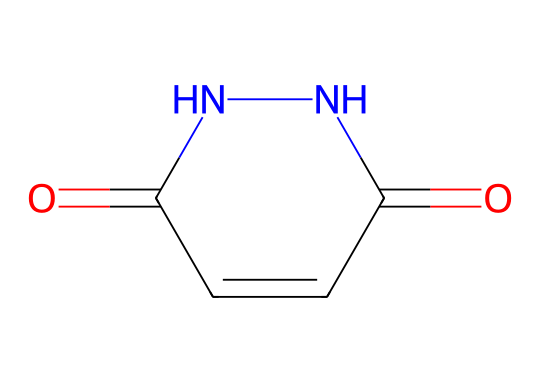What is the primary functional group present in maleic hydrazide? The SMILES structure indicates the presence of a carbonyl group (C=O) and a hydrazine functional group (NN). The carbonyl group is key to its reactivity.
Answer: carbonyl How many nitrogen atoms are in the structure of maleic hydrazide? Analyzing the SMILES, there are two nitrogen atoms denoted by 'N' in the structure. They are part of the hydrazine part of the molecule.
Answer: two What type of ring structure does maleic hydrazide have? The SMILES representation shows a five-membered ring around the nitrogen atoms, typical of hydrazines, with two carbonyl groups attached to it.
Answer: five-membered What effect does the presence of the carbonyl group have on maleic hydrazide's properties? The carbonyl group enhances reactivity, especially in forming bonds with other molecules, which is crucial for its role as a plant growth regulator.
Answer: enhances reactivity What is the total number of rings in the chemical structure of maleic hydrazide? The structure contains one five-membered ring formed by the arrangement of carbon and nitrogen atoms.
Answer: one 